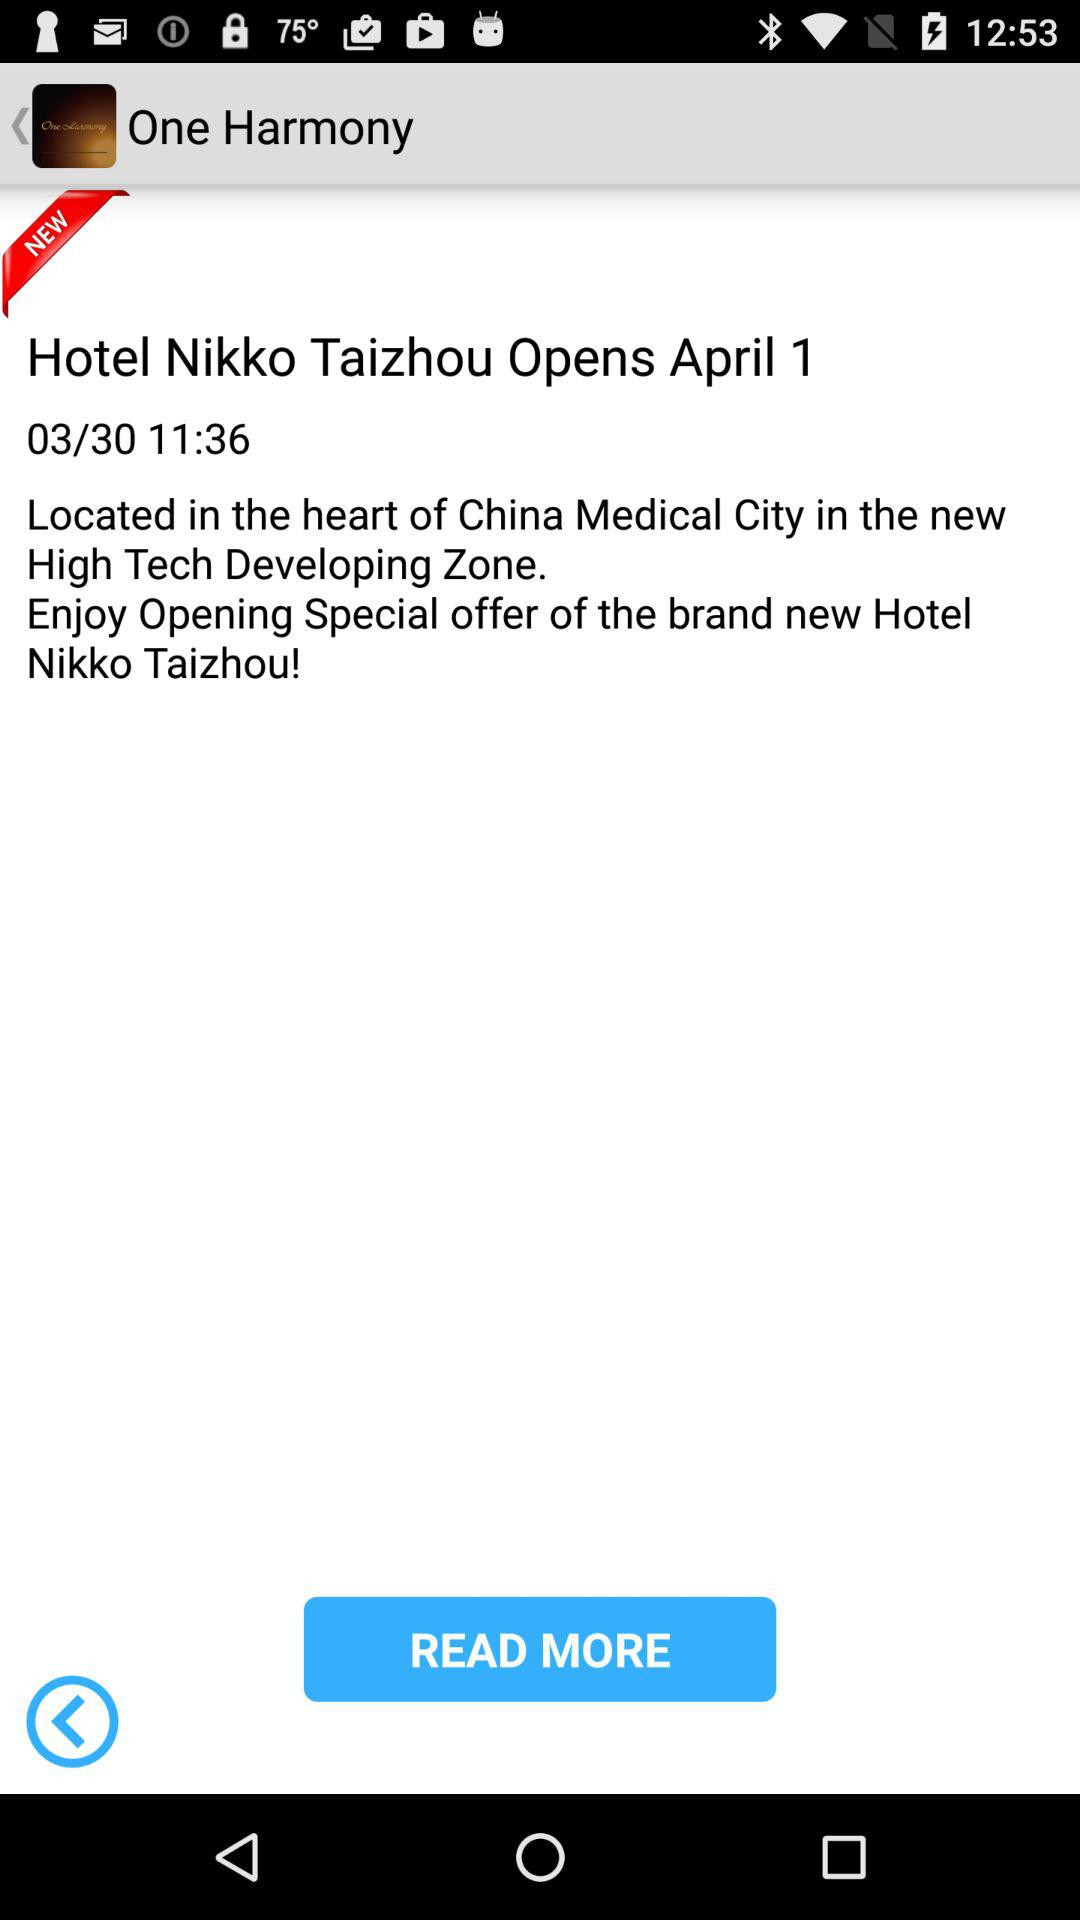Where is the hotel located? The hotel is located in the heart of China's medical city, in the new high-tech development zone. 